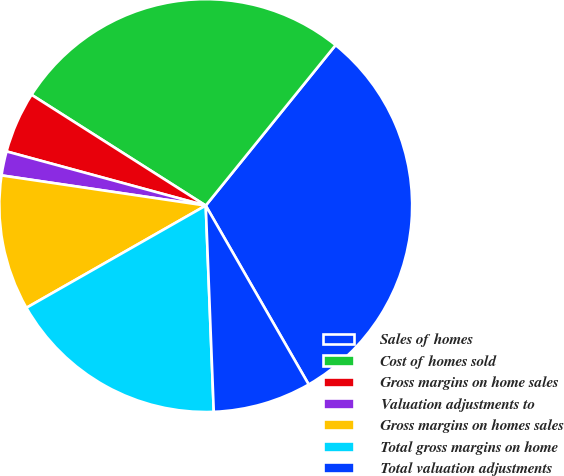<chart> <loc_0><loc_0><loc_500><loc_500><pie_chart><fcel>Sales of homes<fcel>Cost of homes sold<fcel>Gross margins on home sales<fcel>Valuation adjustments to<fcel>Gross margins on homes sales<fcel>Total gross margins on home<fcel>Total valuation adjustments<nl><fcel>30.86%<fcel>26.81%<fcel>4.79%<fcel>1.89%<fcel>10.58%<fcel>17.37%<fcel>7.69%<nl></chart> 